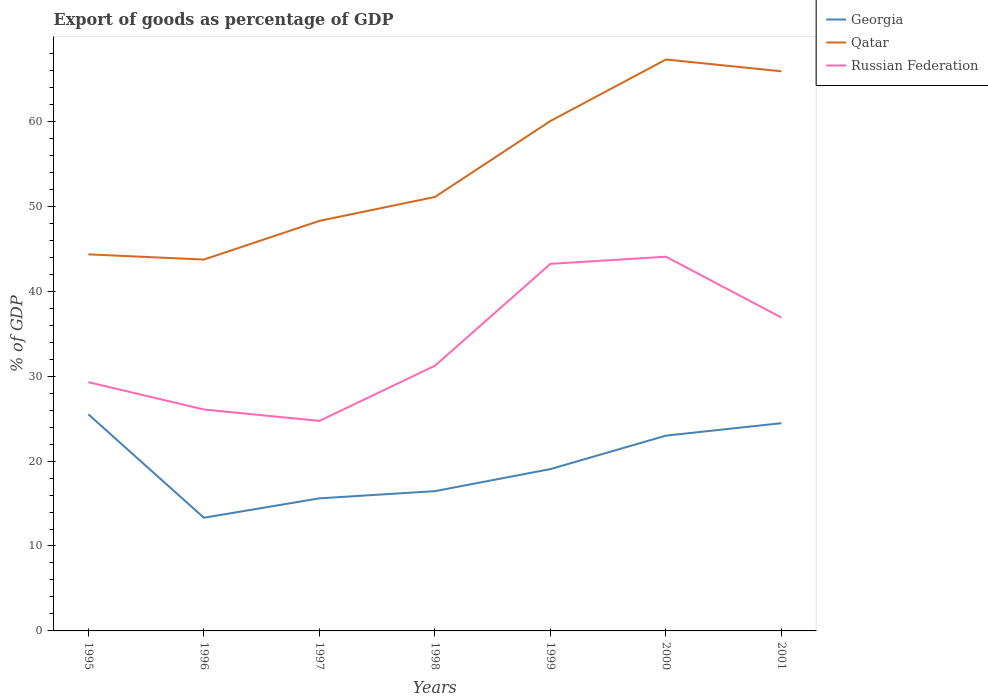How many different coloured lines are there?
Make the answer very short. 3. Does the line corresponding to Qatar intersect with the line corresponding to Georgia?
Offer a terse response. No. Across all years, what is the maximum export of goods as percentage of GDP in Georgia?
Your answer should be compact. 13.33. In which year was the export of goods as percentage of GDP in Qatar maximum?
Ensure brevity in your answer.  1996. What is the total export of goods as percentage of GDP in Qatar in the graph?
Offer a terse response. -16.19. What is the difference between the highest and the second highest export of goods as percentage of GDP in Russian Federation?
Provide a succinct answer. 19.33. What is the difference between the highest and the lowest export of goods as percentage of GDP in Georgia?
Give a very brief answer. 3. Is the export of goods as percentage of GDP in Qatar strictly greater than the export of goods as percentage of GDP in Russian Federation over the years?
Give a very brief answer. No. Are the values on the major ticks of Y-axis written in scientific E-notation?
Offer a very short reply. No. How are the legend labels stacked?
Your response must be concise. Vertical. What is the title of the graph?
Your answer should be compact. Export of goods as percentage of GDP. Does "Central Europe" appear as one of the legend labels in the graph?
Offer a very short reply. No. What is the label or title of the X-axis?
Offer a very short reply. Years. What is the label or title of the Y-axis?
Your answer should be very brief. % of GDP. What is the % of GDP in Georgia in 1995?
Provide a succinct answer. 25.5. What is the % of GDP in Qatar in 1995?
Give a very brief answer. 44.34. What is the % of GDP of Russian Federation in 1995?
Make the answer very short. 29.29. What is the % of GDP of Georgia in 1996?
Your answer should be very brief. 13.33. What is the % of GDP in Qatar in 1996?
Your answer should be very brief. 43.73. What is the % of GDP in Russian Federation in 1996?
Ensure brevity in your answer.  26.07. What is the % of GDP of Georgia in 1997?
Make the answer very short. 15.61. What is the % of GDP in Qatar in 1997?
Provide a short and direct response. 48.28. What is the % of GDP in Russian Federation in 1997?
Give a very brief answer. 24.73. What is the % of GDP of Georgia in 1998?
Your answer should be compact. 16.46. What is the % of GDP in Qatar in 1998?
Your answer should be very brief. 51.1. What is the % of GDP in Russian Federation in 1998?
Your response must be concise. 31.22. What is the % of GDP in Georgia in 1999?
Your response must be concise. 19.06. What is the % of GDP in Qatar in 1999?
Provide a short and direct response. 60.04. What is the % of GDP in Russian Federation in 1999?
Offer a very short reply. 43.22. What is the % of GDP of Georgia in 2000?
Offer a very short reply. 22.99. What is the % of GDP in Qatar in 2000?
Your response must be concise. 67.28. What is the % of GDP in Russian Federation in 2000?
Your response must be concise. 44.06. What is the % of GDP of Georgia in 2001?
Make the answer very short. 24.46. What is the % of GDP of Qatar in 2001?
Ensure brevity in your answer.  65.89. What is the % of GDP of Russian Federation in 2001?
Your response must be concise. 36.89. Across all years, what is the maximum % of GDP of Georgia?
Keep it short and to the point. 25.5. Across all years, what is the maximum % of GDP in Qatar?
Provide a succinct answer. 67.28. Across all years, what is the maximum % of GDP of Russian Federation?
Provide a succinct answer. 44.06. Across all years, what is the minimum % of GDP of Georgia?
Keep it short and to the point. 13.33. Across all years, what is the minimum % of GDP in Qatar?
Provide a succinct answer. 43.73. Across all years, what is the minimum % of GDP in Russian Federation?
Make the answer very short. 24.73. What is the total % of GDP in Georgia in the graph?
Provide a short and direct response. 137.41. What is the total % of GDP in Qatar in the graph?
Make the answer very short. 380.66. What is the total % of GDP in Russian Federation in the graph?
Your answer should be compact. 235.49. What is the difference between the % of GDP of Georgia in 1995 and that in 1996?
Give a very brief answer. 12.18. What is the difference between the % of GDP in Qatar in 1995 and that in 1996?
Your answer should be very brief. 0.61. What is the difference between the % of GDP in Russian Federation in 1995 and that in 1996?
Give a very brief answer. 3.22. What is the difference between the % of GDP of Georgia in 1995 and that in 1997?
Offer a terse response. 9.89. What is the difference between the % of GDP of Qatar in 1995 and that in 1997?
Offer a very short reply. -3.94. What is the difference between the % of GDP of Russian Federation in 1995 and that in 1997?
Offer a terse response. 4.56. What is the difference between the % of GDP of Georgia in 1995 and that in 1998?
Your response must be concise. 9.04. What is the difference between the % of GDP in Qatar in 1995 and that in 1998?
Provide a short and direct response. -6.76. What is the difference between the % of GDP in Russian Federation in 1995 and that in 1998?
Your answer should be very brief. -1.93. What is the difference between the % of GDP in Georgia in 1995 and that in 1999?
Offer a terse response. 6.45. What is the difference between the % of GDP in Qatar in 1995 and that in 1999?
Your answer should be compact. -15.7. What is the difference between the % of GDP of Russian Federation in 1995 and that in 1999?
Give a very brief answer. -13.93. What is the difference between the % of GDP of Georgia in 1995 and that in 2000?
Give a very brief answer. 2.51. What is the difference between the % of GDP in Qatar in 1995 and that in 2000?
Ensure brevity in your answer.  -22.94. What is the difference between the % of GDP in Russian Federation in 1995 and that in 2000?
Keep it short and to the point. -14.77. What is the difference between the % of GDP in Georgia in 1995 and that in 2001?
Your response must be concise. 1.04. What is the difference between the % of GDP of Qatar in 1995 and that in 2001?
Ensure brevity in your answer.  -21.55. What is the difference between the % of GDP in Russian Federation in 1995 and that in 2001?
Provide a succinct answer. -7.6. What is the difference between the % of GDP of Georgia in 1996 and that in 1997?
Make the answer very short. -2.28. What is the difference between the % of GDP in Qatar in 1996 and that in 1997?
Your answer should be compact. -4.56. What is the difference between the % of GDP of Russian Federation in 1996 and that in 1997?
Your answer should be very brief. 1.34. What is the difference between the % of GDP of Georgia in 1996 and that in 1998?
Your response must be concise. -3.13. What is the difference between the % of GDP of Qatar in 1996 and that in 1998?
Keep it short and to the point. -7.37. What is the difference between the % of GDP of Russian Federation in 1996 and that in 1998?
Provide a short and direct response. -5.15. What is the difference between the % of GDP in Georgia in 1996 and that in 1999?
Give a very brief answer. -5.73. What is the difference between the % of GDP in Qatar in 1996 and that in 1999?
Your answer should be very brief. -16.32. What is the difference between the % of GDP of Russian Federation in 1996 and that in 1999?
Your answer should be very brief. -17.15. What is the difference between the % of GDP in Georgia in 1996 and that in 2000?
Your response must be concise. -9.67. What is the difference between the % of GDP of Qatar in 1996 and that in 2000?
Offer a terse response. -23.56. What is the difference between the % of GDP in Russian Federation in 1996 and that in 2000?
Ensure brevity in your answer.  -17.99. What is the difference between the % of GDP in Georgia in 1996 and that in 2001?
Provide a short and direct response. -11.14. What is the difference between the % of GDP of Qatar in 1996 and that in 2001?
Your response must be concise. -22.17. What is the difference between the % of GDP of Russian Federation in 1996 and that in 2001?
Your response must be concise. -10.82. What is the difference between the % of GDP in Georgia in 1997 and that in 1998?
Your answer should be very brief. -0.85. What is the difference between the % of GDP in Qatar in 1997 and that in 1998?
Ensure brevity in your answer.  -2.81. What is the difference between the % of GDP of Russian Federation in 1997 and that in 1998?
Your answer should be compact. -6.49. What is the difference between the % of GDP in Georgia in 1997 and that in 1999?
Ensure brevity in your answer.  -3.45. What is the difference between the % of GDP of Qatar in 1997 and that in 1999?
Make the answer very short. -11.76. What is the difference between the % of GDP of Russian Federation in 1997 and that in 1999?
Ensure brevity in your answer.  -18.49. What is the difference between the % of GDP of Georgia in 1997 and that in 2000?
Your answer should be compact. -7.38. What is the difference between the % of GDP in Qatar in 1997 and that in 2000?
Keep it short and to the point. -19. What is the difference between the % of GDP of Russian Federation in 1997 and that in 2000?
Provide a succinct answer. -19.33. What is the difference between the % of GDP in Georgia in 1997 and that in 2001?
Offer a very short reply. -8.85. What is the difference between the % of GDP in Qatar in 1997 and that in 2001?
Ensure brevity in your answer.  -17.61. What is the difference between the % of GDP of Russian Federation in 1997 and that in 2001?
Provide a succinct answer. -12.16. What is the difference between the % of GDP of Georgia in 1998 and that in 1999?
Offer a very short reply. -2.6. What is the difference between the % of GDP of Qatar in 1998 and that in 1999?
Your response must be concise. -8.95. What is the difference between the % of GDP of Russian Federation in 1998 and that in 1999?
Offer a terse response. -12. What is the difference between the % of GDP of Georgia in 1998 and that in 2000?
Offer a terse response. -6.54. What is the difference between the % of GDP of Qatar in 1998 and that in 2000?
Your response must be concise. -16.19. What is the difference between the % of GDP in Russian Federation in 1998 and that in 2000?
Your answer should be compact. -12.84. What is the difference between the % of GDP of Georgia in 1998 and that in 2001?
Make the answer very short. -8. What is the difference between the % of GDP in Qatar in 1998 and that in 2001?
Your answer should be very brief. -14.8. What is the difference between the % of GDP in Russian Federation in 1998 and that in 2001?
Offer a very short reply. -5.67. What is the difference between the % of GDP in Georgia in 1999 and that in 2000?
Your answer should be compact. -3.94. What is the difference between the % of GDP of Qatar in 1999 and that in 2000?
Your answer should be compact. -7.24. What is the difference between the % of GDP of Russian Federation in 1999 and that in 2000?
Offer a terse response. -0.84. What is the difference between the % of GDP of Georgia in 1999 and that in 2001?
Your response must be concise. -5.41. What is the difference between the % of GDP in Qatar in 1999 and that in 2001?
Provide a short and direct response. -5.85. What is the difference between the % of GDP of Russian Federation in 1999 and that in 2001?
Your answer should be compact. 6.33. What is the difference between the % of GDP in Georgia in 2000 and that in 2001?
Provide a short and direct response. -1.47. What is the difference between the % of GDP in Qatar in 2000 and that in 2001?
Keep it short and to the point. 1.39. What is the difference between the % of GDP of Russian Federation in 2000 and that in 2001?
Ensure brevity in your answer.  7.17. What is the difference between the % of GDP in Georgia in 1995 and the % of GDP in Qatar in 1996?
Give a very brief answer. -18.22. What is the difference between the % of GDP of Georgia in 1995 and the % of GDP of Russian Federation in 1996?
Offer a very short reply. -0.57. What is the difference between the % of GDP of Qatar in 1995 and the % of GDP of Russian Federation in 1996?
Your response must be concise. 18.27. What is the difference between the % of GDP in Georgia in 1995 and the % of GDP in Qatar in 1997?
Your answer should be very brief. -22.78. What is the difference between the % of GDP in Georgia in 1995 and the % of GDP in Russian Federation in 1997?
Your answer should be very brief. 0.77. What is the difference between the % of GDP in Qatar in 1995 and the % of GDP in Russian Federation in 1997?
Offer a terse response. 19.61. What is the difference between the % of GDP of Georgia in 1995 and the % of GDP of Qatar in 1998?
Keep it short and to the point. -25.59. What is the difference between the % of GDP in Georgia in 1995 and the % of GDP in Russian Federation in 1998?
Your response must be concise. -5.72. What is the difference between the % of GDP of Qatar in 1995 and the % of GDP of Russian Federation in 1998?
Offer a very short reply. 13.12. What is the difference between the % of GDP in Georgia in 1995 and the % of GDP in Qatar in 1999?
Your response must be concise. -34.54. What is the difference between the % of GDP of Georgia in 1995 and the % of GDP of Russian Federation in 1999?
Your answer should be very brief. -17.72. What is the difference between the % of GDP in Qatar in 1995 and the % of GDP in Russian Federation in 1999?
Give a very brief answer. 1.12. What is the difference between the % of GDP of Georgia in 1995 and the % of GDP of Qatar in 2000?
Offer a very short reply. -41.78. What is the difference between the % of GDP in Georgia in 1995 and the % of GDP in Russian Federation in 2000?
Keep it short and to the point. -18.56. What is the difference between the % of GDP of Qatar in 1995 and the % of GDP of Russian Federation in 2000?
Offer a very short reply. 0.28. What is the difference between the % of GDP in Georgia in 1995 and the % of GDP in Qatar in 2001?
Your answer should be very brief. -40.39. What is the difference between the % of GDP of Georgia in 1995 and the % of GDP of Russian Federation in 2001?
Make the answer very short. -11.39. What is the difference between the % of GDP of Qatar in 1995 and the % of GDP of Russian Federation in 2001?
Your response must be concise. 7.45. What is the difference between the % of GDP of Georgia in 1996 and the % of GDP of Qatar in 1997?
Your answer should be very brief. -34.95. What is the difference between the % of GDP of Georgia in 1996 and the % of GDP of Russian Federation in 1997?
Give a very brief answer. -11.4. What is the difference between the % of GDP in Qatar in 1996 and the % of GDP in Russian Federation in 1997?
Make the answer very short. 19. What is the difference between the % of GDP in Georgia in 1996 and the % of GDP in Qatar in 1998?
Your answer should be compact. -37.77. What is the difference between the % of GDP in Georgia in 1996 and the % of GDP in Russian Federation in 1998?
Offer a terse response. -17.9. What is the difference between the % of GDP of Qatar in 1996 and the % of GDP of Russian Federation in 1998?
Your answer should be compact. 12.5. What is the difference between the % of GDP in Georgia in 1996 and the % of GDP in Qatar in 1999?
Provide a short and direct response. -46.71. What is the difference between the % of GDP in Georgia in 1996 and the % of GDP in Russian Federation in 1999?
Your answer should be compact. -29.89. What is the difference between the % of GDP in Qatar in 1996 and the % of GDP in Russian Federation in 1999?
Ensure brevity in your answer.  0.51. What is the difference between the % of GDP in Georgia in 1996 and the % of GDP in Qatar in 2000?
Your answer should be very brief. -53.96. What is the difference between the % of GDP in Georgia in 1996 and the % of GDP in Russian Federation in 2000?
Make the answer very short. -30.73. What is the difference between the % of GDP of Qatar in 1996 and the % of GDP of Russian Federation in 2000?
Your response must be concise. -0.34. What is the difference between the % of GDP of Georgia in 1996 and the % of GDP of Qatar in 2001?
Provide a short and direct response. -52.57. What is the difference between the % of GDP in Georgia in 1996 and the % of GDP in Russian Federation in 2001?
Make the answer very short. -23.57. What is the difference between the % of GDP of Qatar in 1996 and the % of GDP of Russian Federation in 2001?
Offer a very short reply. 6.83. What is the difference between the % of GDP of Georgia in 1997 and the % of GDP of Qatar in 1998?
Provide a succinct answer. -35.49. What is the difference between the % of GDP of Georgia in 1997 and the % of GDP of Russian Federation in 1998?
Keep it short and to the point. -15.61. What is the difference between the % of GDP in Qatar in 1997 and the % of GDP in Russian Federation in 1998?
Offer a very short reply. 17.06. What is the difference between the % of GDP in Georgia in 1997 and the % of GDP in Qatar in 1999?
Your response must be concise. -44.43. What is the difference between the % of GDP of Georgia in 1997 and the % of GDP of Russian Federation in 1999?
Offer a very short reply. -27.61. What is the difference between the % of GDP of Qatar in 1997 and the % of GDP of Russian Federation in 1999?
Offer a very short reply. 5.06. What is the difference between the % of GDP of Georgia in 1997 and the % of GDP of Qatar in 2000?
Give a very brief answer. -51.67. What is the difference between the % of GDP of Georgia in 1997 and the % of GDP of Russian Federation in 2000?
Ensure brevity in your answer.  -28.45. What is the difference between the % of GDP of Qatar in 1997 and the % of GDP of Russian Federation in 2000?
Your answer should be very brief. 4.22. What is the difference between the % of GDP of Georgia in 1997 and the % of GDP of Qatar in 2001?
Provide a short and direct response. -50.28. What is the difference between the % of GDP in Georgia in 1997 and the % of GDP in Russian Federation in 2001?
Your answer should be compact. -21.28. What is the difference between the % of GDP of Qatar in 1997 and the % of GDP of Russian Federation in 2001?
Your response must be concise. 11.39. What is the difference between the % of GDP of Georgia in 1998 and the % of GDP of Qatar in 1999?
Provide a short and direct response. -43.58. What is the difference between the % of GDP of Georgia in 1998 and the % of GDP of Russian Federation in 1999?
Your answer should be compact. -26.76. What is the difference between the % of GDP of Qatar in 1998 and the % of GDP of Russian Federation in 1999?
Keep it short and to the point. 7.88. What is the difference between the % of GDP in Georgia in 1998 and the % of GDP in Qatar in 2000?
Your answer should be very brief. -50.82. What is the difference between the % of GDP of Georgia in 1998 and the % of GDP of Russian Federation in 2000?
Offer a very short reply. -27.6. What is the difference between the % of GDP of Qatar in 1998 and the % of GDP of Russian Federation in 2000?
Provide a succinct answer. 7.03. What is the difference between the % of GDP of Georgia in 1998 and the % of GDP of Qatar in 2001?
Make the answer very short. -49.43. What is the difference between the % of GDP in Georgia in 1998 and the % of GDP in Russian Federation in 2001?
Give a very brief answer. -20.43. What is the difference between the % of GDP in Qatar in 1998 and the % of GDP in Russian Federation in 2001?
Your answer should be very brief. 14.2. What is the difference between the % of GDP in Georgia in 1999 and the % of GDP in Qatar in 2000?
Give a very brief answer. -48.23. What is the difference between the % of GDP in Georgia in 1999 and the % of GDP in Russian Federation in 2000?
Provide a succinct answer. -25.01. What is the difference between the % of GDP in Qatar in 1999 and the % of GDP in Russian Federation in 2000?
Keep it short and to the point. 15.98. What is the difference between the % of GDP of Georgia in 1999 and the % of GDP of Qatar in 2001?
Your response must be concise. -46.84. What is the difference between the % of GDP of Georgia in 1999 and the % of GDP of Russian Federation in 2001?
Provide a succinct answer. -17.84. What is the difference between the % of GDP in Qatar in 1999 and the % of GDP in Russian Federation in 2001?
Keep it short and to the point. 23.15. What is the difference between the % of GDP in Georgia in 2000 and the % of GDP in Qatar in 2001?
Ensure brevity in your answer.  -42.9. What is the difference between the % of GDP in Georgia in 2000 and the % of GDP in Russian Federation in 2001?
Offer a very short reply. -13.9. What is the difference between the % of GDP in Qatar in 2000 and the % of GDP in Russian Federation in 2001?
Offer a terse response. 30.39. What is the average % of GDP of Georgia per year?
Ensure brevity in your answer.  19.63. What is the average % of GDP of Qatar per year?
Your answer should be compact. 54.38. What is the average % of GDP of Russian Federation per year?
Give a very brief answer. 33.64. In the year 1995, what is the difference between the % of GDP of Georgia and % of GDP of Qatar?
Provide a short and direct response. -18.84. In the year 1995, what is the difference between the % of GDP of Georgia and % of GDP of Russian Federation?
Make the answer very short. -3.79. In the year 1995, what is the difference between the % of GDP of Qatar and % of GDP of Russian Federation?
Keep it short and to the point. 15.05. In the year 1996, what is the difference between the % of GDP in Georgia and % of GDP in Qatar?
Keep it short and to the point. -30.4. In the year 1996, what is the difference between the % of GDP in Georgia and % of GDP in Russian Federation?
Your response must be concise. -12.75. In the year 1996, what is the difference between the % of GDP in Qatar and % of GDP in Russian Federation?
Provide a succinct answer. 17.65. In the year 1997, what is the difference between the % of GDP of Georgia and % of GDP of Qatar?
Provide a succinct answer. -32.67. In the year 1997, what is the difference between the % of GDP in Georgia and % of GDP in Russian Federation?
Your answer should be compact. -9.12. In the year 1997, what is the difference between the % of GDP in Qatar and % of GDP in Russian Federation?
Your response must be concise. 23.55. In the year 1998, what is the difference between the % of GDP in Georgia and % of GDP in Qatar?
Offer a very short reply. -34.64. In the year 1998, what is the difference between the % of GDP of Georgia and % of GDP of Russian Federation?
Your response must be concise. -14.76. In the year 1998, what is the difference between the % of GDP in Qatar and % of GDP in Russian Federation?
Ensure brevity in your answer.  19.87. In the year 1999, what is the difference between the % of GDP in Georgia and % of GDP in Qatar?
Provide a short and direct response. -40.99. In the year 1999, what is the difference between the % of GDP of Georgia and % of GDP of Russian Federation?
Keep it short and to the point. -24.16. In the year 1999, what is the difference between the % of GDP in Qatar and % of GDP in Russian Federation?
Make the answer very short. 16.82. In the year 2000, what is the difference between the % of GDP of Georgia and % of GDP of Qatar?
Make the answer very short. -44.29. In the year 2000, what is the difference between the % of GDP in Georgia and % of GDP in Russian Federation?
Give a very brief answer. -21.07. In the year 2000, what is the difference between the % of GDP in Qatar and % of GDP in Russian Federation?
Offer a very short reply. 23.22. In the year 2001, what is the difference between the % of GDP of Georgia and % of GDP of Qatar?
Your answer should be very brief. -41.43. In the year 2001, what is the difference between the % of GDP in Georgia and % of GDP in Russian Federation?
Give a very brief answer. -12.43. In the year 2001, what is the difference between the % of GDP in Qatar and % of GDP in Russian Federation?
Offer a very short reply. 29. What is the ratio of the % of GDP in Georgia in 1995 to that in 1996?
Give a very brief answer. 1.91. What is the ratio of the % of GDP of Qatar in 1995 to that in 1996?
Provide a short and direct response. 1.01. What is the ratio of the % of GDP of Russian Federation in 1995 to that in 1996?
Provide a succinct answer. 1.12. What is the ratio of the % of GDP of Georgia in 1995 to that in 1997?
Your answer should be very brief. 1.63. What is the ratio of the % of GDP in Qatar in 1995 to that in 1997?
Your answer should be very brief. 0.92. What is the ratio of the % of GDP of Russian Federation in 1995 to that in 1997?
Provide a short and direct response. 1.18. What is the ratio of the % of GDP in Georgia in 1995 to that in 1998?
Provide a short and direct response. 1.55. What is the ratio of the % of GDP of Qatar in 1995 to that in 1998?
Your response must be concise. 0.87. What is the ratio of the % of GDP of Russian Federation in 1995 to that in 1998?
Give a very brief answer. 0.94. What is the ratio of the % of GDP of Georgia in 1995 to that in 1999?
Provide a succinct answer. 1.34. What is the ratio of the % of GDP in Qatar in 1995 to that in 1999?
Keep it short and to the point. 0.74. What is the ratio of the % of GDP in Russian Federation in 1995 to that in 1999?
Provide a succinct answer. 0.68. What is the ratio of the % of GDP of Georgia in 1995 to that in 2000?
Offer a very short reply. 1.11. What is the ratio of the % of GDP of Qatar in 1995 to that in 2000?
Your answer should be compact. 0.66. What is the ratio of the % of GDP in Russian Federation in 1995 to that in 2000?
Keep it short and to the point. 0.66. What is the ratio of the % of GDP in Georgia in 1995 to that in 2001?
Provide a short and direct response. 1.04. What is the ratio of the % of GDP of Qatar in 1995 to that in 2001?
Provide a short and direct response. 0.67. What is the ratio of the % of GDP in Russian Federation in 1995 to that in 2001?
Provide a short and direct response. 0.79. What is the ratio of the % of GDP of Georgia in 1996 to that in 1997?
Keep it short and to the point. 0.85. What is the ratio of the % of GDP in Qatar in 1996 to that in 1997?
Make the answer very short. 0.91. What is the ratio of the % of GDP in Russian Federation in 1996 to that in 1997?
Your response must be concise. 1.05. What is the ratio of the % of GDP in Georgia in 1996 to that in 1998?
Offer a very short reply. 0.81. What is the ratio of the % of GDP of Qatar in 1996 to that in 1998?
Your answer should be compact. 0.86. What is the ratio of the % of GDP in Russian Federation in 1996 to that in 1998?
Give a very brief answer. 0.84. What is the ratio of the % of GDP in Georgia in 1996 to that in 1999?
Offer a very short reply. 0.7. What is the ratio of the % of GDP in Qatar in 1996 to that in 1999?
Offer a terse response. 0.73. What is the ratio of the % of GDP of Russian Federation in 1996 to that in 1999?
Offer a terse response. 0.6. What is the ratio of the % of GDP of Georgia in 1996 to that in 2000?
Your response must be concise. 0.58. What is the ratio of the % of GDP of Qatar in 1996 to that in 2000?
Your response must be concise. 0.65. What is the ratio of the % of GDP in Russian Federation in 1996 to that in 2000?
Offer a terse response. 0.59. What is the ratio of the % of GDP in Georgia in 1996 to that in 2001?
Keep it short and to the point. 0.54. What is the ratio of the % of GDP of Qatar in 1996 to that in 2001?
Your answer should be compact. 0.66. What is the ratio of the % of GDP of Russian Federation in 1996 to that in 2001?
Your answer should be very brief. 0.71. What is the ratio of the % of GDP of Georgia in 1997 to that in 1998?
Give a very brief answer. 0.95. What is the ratio of the % of GDP in Qatar in 1997 to that in 1998?
Provide a succinct answer. 0.94. What is the ratio of the % of GDP in Russian Federation in 1997 to that in 1998?
Your answer should be compact. 0.79. What is the ratio of the % of GDP in Georgia in 1997 to that in 1999?
Give a very brief answer. 0.82. What is the ratio of the % of GDP in Qatar in 1997 to that in 1999?
Your answer should be very brief. 0.8. What is the ratio of the % of GDP in Russian Federation in 1997 to that in 1999?
Provide a short and direct response. 0.57. What is the ratio of the % of GDP in Georgia in 1997 to that in 2000?
Offer a very short reply. 0.68. What is the ratio of the % of GDP of Qatar in 1997 to that in 2000?
Your answer should be very brief. 0.72. What is the ratio of the % of GDP of Russian Federation in 1997 to that in 2000?
Offer a very short reply. 0.56. What is the ratio of the % of GDP of Georgia in 1997 to that in 2001?
Provide a succinct answer. 0.64. What is the ratio of the % of GDP in Qatar in 1997 to that in 2001?
Your answer should be compact. 0.73. What is the ratio of the % of GDP in Russian Federation in 1997 to that in 2001?
Offer a terse response. 0.67. What is the ratio of the % of GDP in Georgia in 1998 to that in 1999?
Keep it short and to the point. 0.86. What is the ratio of the % of GDP in Qatar in 1998 to that in 1999?
Offer a very short reply. 0.85. What is the ratio of the % of GDP in Russian Federation in 1998 to that in 1999?
Keep it short and to the point. 0.72. What is the ratio of the % of GDP in Georgia in 1998 to that in 2000?
Provide a succinct answer. 0.72. What is the ratio of the % of GDP of Qatar in 1998 to that in 2000?
Your response must be concise. 0.76. What is the ratio of the % of GDP of Russian Federation in 1998 to that in 2000?
Provide a succinct answer. 0.71. What is the ratio of the % of GDP in Georgia in 1998 to that in 2001?
Your answer should be compact. 0.67. What is the ratio of the % of GDP of Qatar in 1998 to that in 2001?
Give a very brief answer. 0.78. What is the ratio of the % of GDP of Russian Federation in 1998 to that in 2001?
Provide a short and direct response. 0.85. What is the ratio of the % of GDP of Georgia in 1999 to that in 2000?
Your answer should be compact. 0.83. What is the ratio of the % of GDP of Qatar in 1999 to that in 2000?
Offer a very short reply. 0.89. What is the ratio of the % of GDP in Russian Federation in 1999 to that in 2000?
Your response must be concise. 0.98. What is the ratio of the % of GDP of Georgia in 1999 to that in 2001?
Give a very brief answer. 0.78. What is the ratio of the % of GDP of Qatar in 1999 to that in 2001?
Provide a short and direct response. 0.91. What is the ratio of the % of GDP in Russian Federation in 1999 to that in 2001?
Provide a succinct answer. 1.17. What is the ratio of the % of GDP of Qatar in 2000 to that in 2001?
Your answer should be compact. 1.02. What is the ratio of the % of GDP of Russian Federation in 2000 to that in 2001?
Ensure brevity in your answer.  1.19. What is the difference between the highest and the second highest % of GDP of Georgia?
Your answer should be very brief. 1.04. What is the difference between the highest and the second highest % of GDP in Qatar?
Keep it short and to the point. 1.39. What is the difference between the highest and the second highest % of GDP in Russian Federation?
Make the answer very short. 0.84. What is the difference between the highest and the lowest % of GDP of Georgia?
Ensure brevity in your answer.  12.18. What is the difference between the highest and the lowest % of GDP in Qatar?
Offer a very short reply. 23.56. What is the difference between the highest and the lowest % of GDP of Russian Federation?
Offer a very short reply. 19.33. 